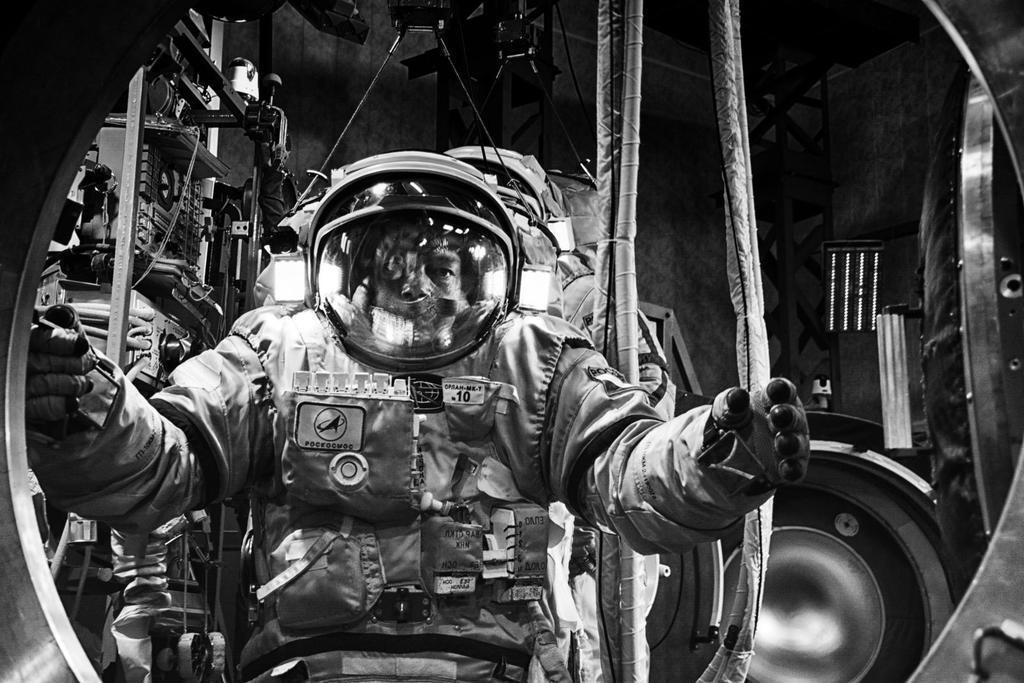How would you summarize this image in a sentence or two? This is a black and white image. In this image we can see astronaut. In the background we can see objects placed in shelves and wall. 